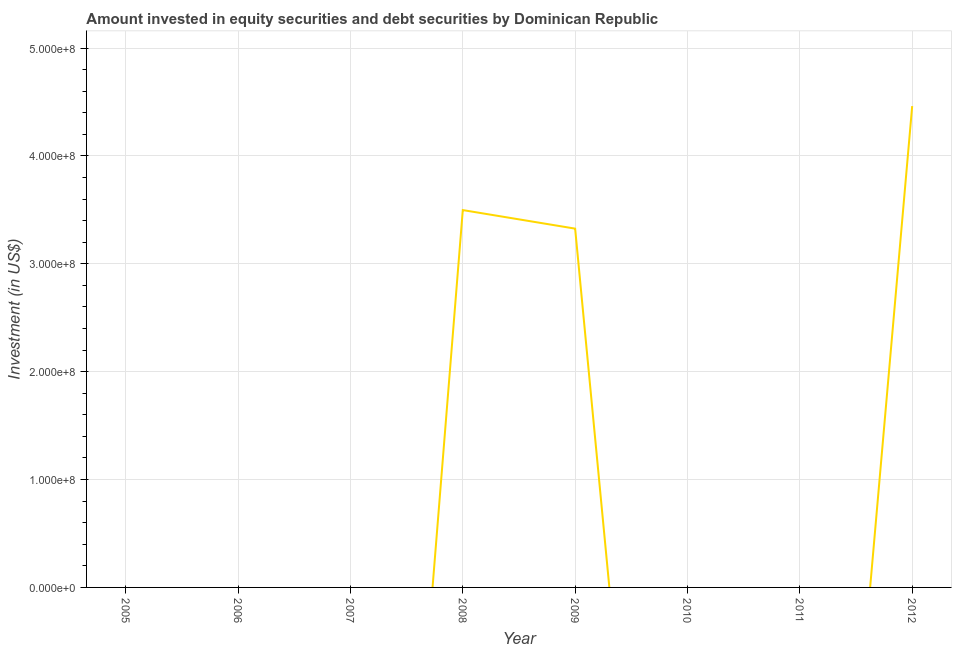Across all years, what is the maximum portfolio investment?
Offer a very short reply. 4.46e+08. In which year was the portfolio investment maximum?
Offer a very short reply. 2012. What is the sum of the portfolio investment?
Provide a short and direct response. 1.13e+09. What is the difference between the portfolio investment in 2008 and 2009?
Offer a terse response. 1.72e+07. What is the average portfolio investment per year?
Keep it short and to the point. 1.41e+08. In how many years, is the portfolio investment greater than 240000000 US$?
Provide a succinct answer. 3. What is the ratio of the portfolio investment in 2008 to that in 2009?
Give a very brief answer. 1.05. What is the difference between the highest and the second highest portfolio investment?
Offer a terse response. 9.64e+07. What is the difference between the highest and the lowest portfolio investment?
Give a very brief answer. 4.46e+08. Does the portfolio investment monotonically increase over the years?
Offer a terse response. No. How many lines are there?
Your answer should be compact. 1. How many years are there in the graph?
Offer a very short reply. 8. Does the graph contain any zero values?
Keep it short and to the point. Yes. What is the title of the graph?
Ensure brevity in your answer.  Amount invested in equity securities and debt securities by Dominican Republic. What is the label or title of the X-axis?
Offer a very short reply. Year. What is the label or title of the Y-axis?
Your answer should be compact. Investment (in US$). What is the Investment (in US$) of 2005?
Give a very brief answer. 0. What is the Investment (in US$) in 2006?
Your answer should be compact. 0. What is the Investment (in US$) in 2008?
Provide a succinct answer. 3.50e+08. What is the Investment (in US$) of 2009?
Provide a short and direct response. 3.33e+08. What is the Investment (in US$) of 2010?
Give a very brief answer. 0. What is the Investment (in US$) of 2011?
Your answer should be very brief. 0. What is the Investment (in US$) in 2012?
Your answer should be very brief. 4.46e+08. What is the difference between the Investment (in US$) in 2008 and 2009?
Give a very brief answer. 1.72e+07. What is the difference between the Investment (in US$) in 2008 and 2012?
Provide a short and direct response. -9.64e+07. What is the difference between the Investment (in US$) in 2009 and 2012?
Your answer should be compact. -1.14e+08. What is the ratio of the Investment (in US$) in 2008 to that in 2009?
Make the answer very short. 1.05. What is the ratio of the Investment (in US$) in 2008 to that in 2012?
Your answer should be compact. 0.78. What is the ratio of the Investment (in US$) in 2009 to that in 2012?
Provide a succinct answer. 0.74. 